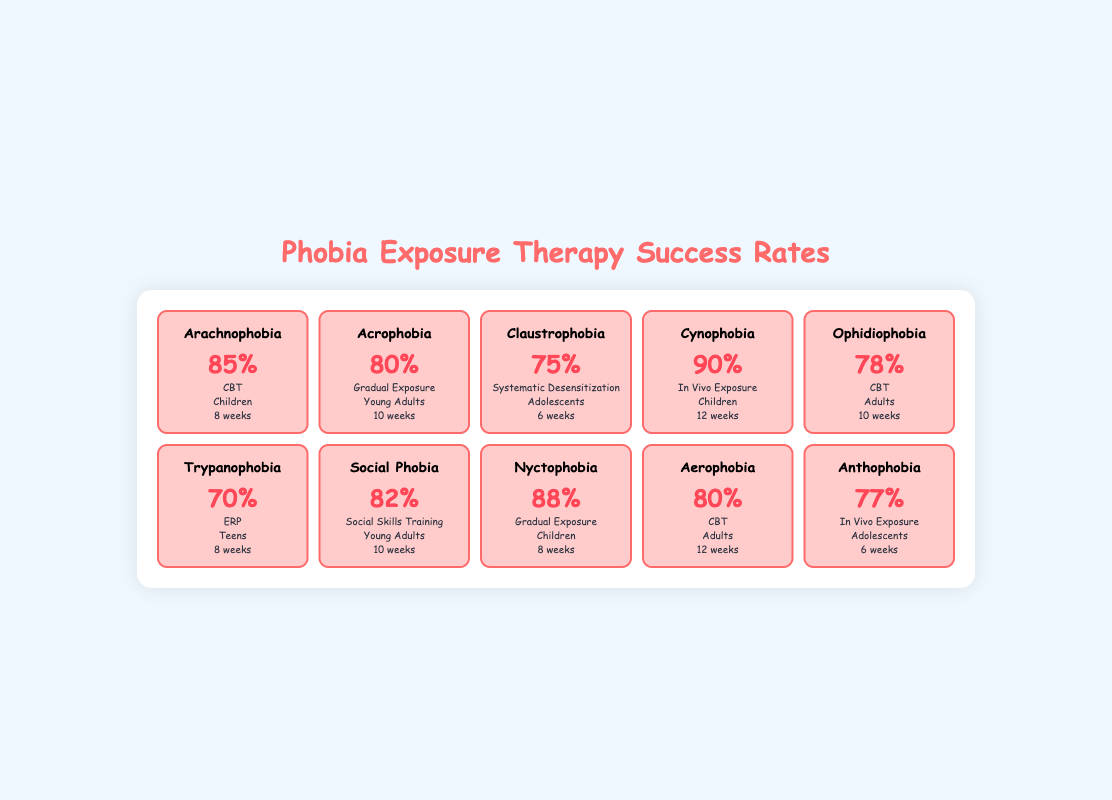What is the success rate of Arachnophobia treatment? The success rate for Arachnophobia, as mentioned in the table, is listed directly under the success rate column for Arachnophobia. It states 85%.
Answer: 85% Which phobia has the highest success rate? By comparing the success rates in the table, Cynophobia has the highest success rate at 90%.
Answer: 90% What is the average success rate of treatments for phobias in children? The success rates for phobias in children are Arachnophobia (85%), Cynophobia (90%), and Nyctophobia (88%). Summing these gives 85 + 90 + 88 = 263, and there are 3 data points, so the average is 263/3 = approximately 87.67.
Answer: Approximately 87.67 Does Social Phobia have a success rate lower than 80%? Looking at the table under Social Phobia, its success rate is listed as 82%. Since 82 is greater than 80, the answer is no.
Answer: No What is the success rate difference between Acrophobia and Claustrophobia? The success rate for Acrophobia is 80% and for Claustrophobia is 75%. The difference is calculated by subtracting Claustrophobia's success rate from Acrophobia’s, which is 80 - 75 = 5%.
Answer: 5% How many weeks of treatment are needed on average for phobias treated with Virtual Reality? The durations for Virtual Reality treatments are: Arachnophobia (8 weeks), Acrophobia (10 weeks), Claustrophobia (6 weeks), Cynophobia (12 weeks), Ophidiophobia (10 weeks), Trypanophobia (8 weeks), Social Phobia (10 weeks), Nyctophobia (8 weeks), Aerophobia (12 weeks), and these can be summed: 8 + 10 + 6 + 12 + 10 + 8 + 10 + 8 + 12 = 88 weeks. Dividing by the 10 data points gives an average of 88/10 = 8.8 weeks.
Answer: 8.8 weeks Is In Vivo Exposure the treatment method for Phobias with success rates above 80%? In Vivo Exposure is used for Cynophobia with a success rate of 90%, but it is also used for Anthophobia with a rate of 77%. So, yes, it has one case above 80% but also one below. Thus, the answer is yes.
Answer: Yes Which age group has the highest average success rate? The age groups and their rates are: Children (Arachnophobia 85% + Cynophobia 90% + Nyctophobia 88% = 87.67), Young Adults (Acrophobia 80% + Social Phobia 82% = 81%), Adolescents (Claustrophobia 75% + Anthophobia 77% = 76%), Teens (Trypanophobia 70% = 70%), Adults (Ophidiophobia 78% + Aerophobia 80% = 79%). The highest average is for Children at approximately 87.67%.
Answer: Children 